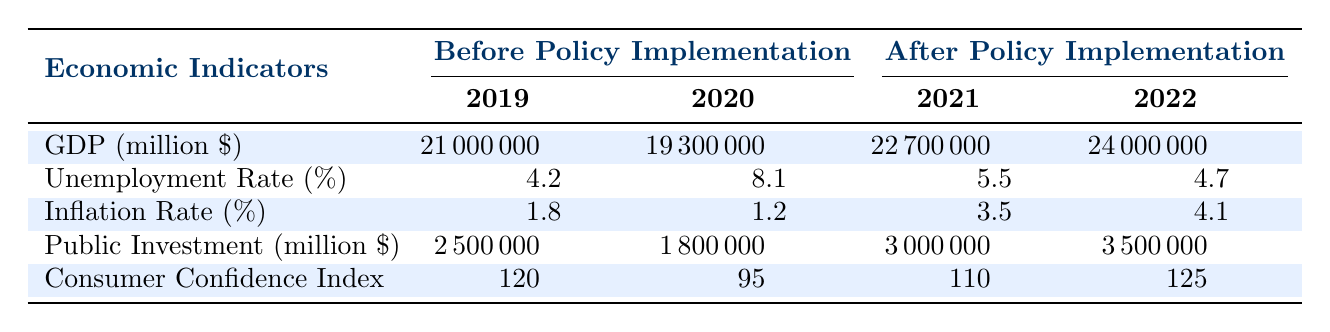What was the GDP in 2019? The table shows that the GDP in 2019 was 21000000 million dollars. This information can be found under the GDP row in the Before Policy Implementation section for the year 2019.
Answer: 21000000 million dollars What was the unemployment rate in 2022? Referring to the table, the unemployment rate in 2022 is listed under the Unemployment Rate row in the After Policy Implementation section, which shows a value of 4.7%.
Answer: 4.7% By how much did public investment increase from 2020 to 2021? To find the increase in public investment from 2020 to 2021, we subtract the value in 2020 (1800000 million dollars) from the value in 2021 (3000000 million dollars). The difference is 3000000 - 1800000 = 1200000 million dollars.
Answer: 1200000 million dollars Was the inflation rate higher after the policy implementation in both years compared to 2019? Looking at the inflation rates, in 2019 it was 1.8%. In 2021, it rose to 3.5%, and in 2022 it further increased to 4.1%. Since both 2021 and 2022 rates are higher than 2019, the answer is yes.
Answer: Yes What is the average consumer confidence index for the years before the policy implementation? To calculate the average consumer confidence index before policy implementation, we take the values from 2019 (120) and 2020 (95). Adding these gives us 120 + 95 = 215. Dividing by 2 gives us the average: 215 / 2 = 107.5.
Answer: 107.5 